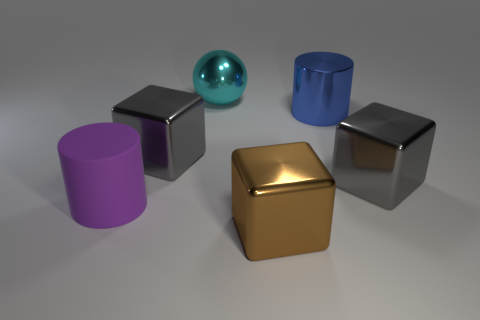Subtract all gray cubes. How many cubes are left? 1 Add 3 large cyan balls. How many objects exist? 9 Subtract all spheres. How many objects are left? 5 Add 5 large blue cylinders. How many large blue cylinders are left? 6 Add 3 blue shiny cylinders. How many blue shiny cylinders exist? 4 Subtract 0 cyan cylinders. How many objects are left? 6 Subtract all cyan shiny spheres. Subtract all large metal things. How many objects are left? 0 